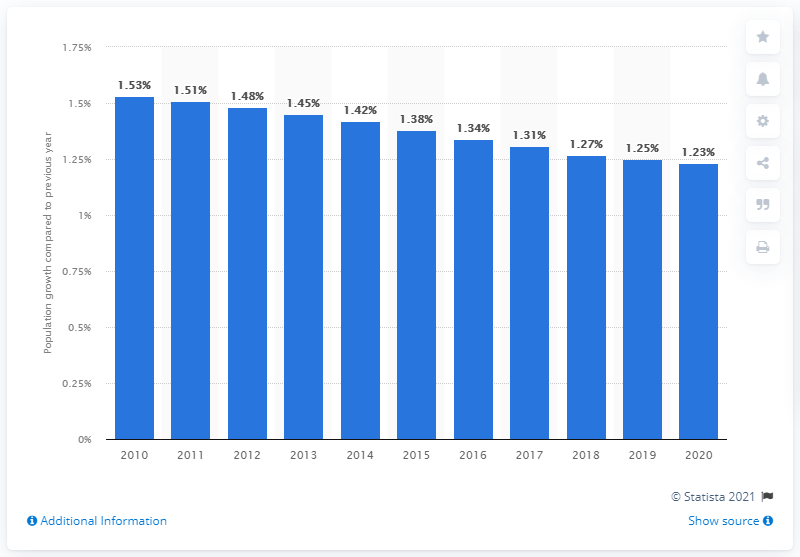Indicate a few pertinent items in this graphic. According to the data, Haiti's population increased by 1.23% in 2020. 